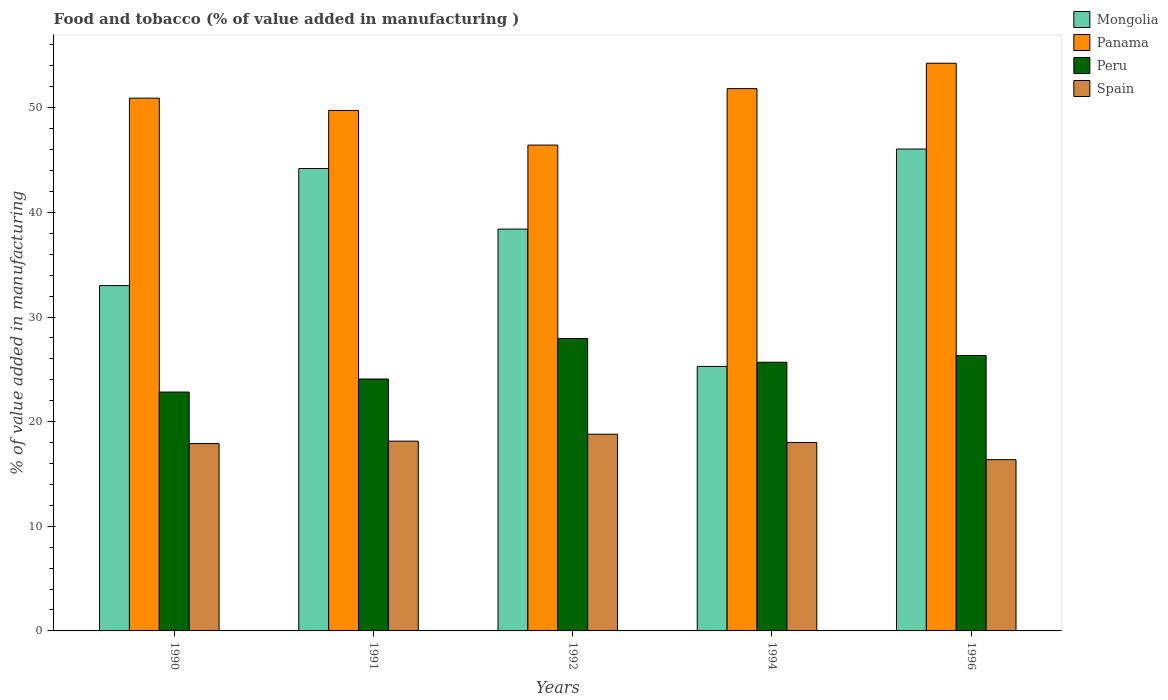How many different coloured bars are there?
Keep it short and to the point. 4. How many groups of bars are there?
Offer a very short reply. 5. Are the number of bars per tick equal to the number of legend labels?
Provide a succinct answer. Yes. How many bars are there on the 3rd tick from the right?
Provide a short and direct response. 4. In how many cases, is the number of bars for a given year not equal to the number of legend labels?
Ensure brevity in your answer.  0. What is the value added in manufacturing food and tobacco in Panama in 1992?
Make the answer very short. 46.43. Across all years, what is the maximum value added in manufacturing food and tobacco in Spain?
Your answer should be compact. 18.8. Across all years, what is the minimum value added in manufacturing food and tobacco in Spain?
Ensure brevity in your answer.  16.37. In which year was the value added in manufacturing food and tobacco in Panama maximum?
Your answer should be compact. 1996. What is the total value added in manufacturing food and tobacco in Mongolia in the graph?
Your answer should be very brief. 186.94. What is the difference between the value added in manufacturing food and tobacco in Panama in 1990 and that in 1991?
Your response must be concise. 1.17. What is the difference between the value added in manufacturing food and tobacco in Mongolia in 1996 and the value added in manufacturing food and tobacco in Spain in 1990?
Offer a terse response. 28.15. What is the average value added in manufacturing food and tobacco in Mongolia per year?
Make the answer very short. 37.39. In the year 1992, what is the difference between the value added in manufacturing food and tobacco in Panama and value added in manufacturing food and tobacco in Spain?
Give a very brief answer. 27.63. What is the ratio of the value added in manufacturing food and tobacco in Spain in 1991 to that in 1994?
Your answer should be compact. 1.01. Is the difference between the value added in manufacturing food and tobacco in Panama in 1990 and 1996 greater than the difference between the value added in manufacturing food and tobacco in Spain in 1990 and 1996?
Ensure brevity in your answer.  No. What is the difference between the highest and the second highest value added in manufacturing food and tobacco in Panama?
Offer a terse response. 2.42. What is the difference between the highest and the lowest value added in manufacturing food and tobacco in Panama?
Your answer should be very brief. 7.82. In how many years, is the value added in manufacturing food and tobacco in Mongolia greater than the average value added in manufacturing food and tobacco in Mongolia taken over all years?
Keep it short and to the point. 3. What does the 3rd bar from the left in 1990 represents?
Give a very brief answer. Peru. What does the 2nd bar from the right in 1991 represents?
Provide a succinct answer. Peru. How many bars are there?
Your response must be concise. 20. Are the values on the major ticks of Y-axis written in scientific E-notation?
Offer a terse response. No. Where does the legend appear in the graph?
Give a very brief answer. Top right. What is the title of the graph?
Ensure brevity in your answer.  Food and tobacco (% of value added in manufacturing ). What is the label or title of the X-axis?
Keep it short and to the point. Years. What is the label or title of the Y-axis?
Provide a succinct answer. % of value added in manufacturing. What is the % of value added in manufacturing in Mongolia in 1990?
Provide a short and direct response. 33.01. What is the % of value added in manufacturing in Panama in 1990?
Provide a short and direct response. 50.92. What is the % of value added in manufacturing of Peru in 1990?
Give a very brief answer. 22.83. What is the % of value added in manufacturing of Spain in 1990?
Give a very brief answer. 17.9. What is the % of value added in manufacturing in Mongolia in 1991?
Your answer should be compact. 44.2. What is the % of value added in manufacturing of Panama in 1991?
Offer a terse response. 49.75. What is the % of value added in manufacturing of Peru in 1991?
Offer a terse response. 24.08. What is the % of value added in manufacturing in Spain in 1991?
Your response must be concise. 18.14. What is the % of value added in manufacturing in Mongolia in 1992?
Offer a very short reply. 38.41. What is the % of value added in manufacturing in Panama in 1992?
Your answer should be compact. 46.43. What is the % of value added in manufacturing of Peru in 1992?
Ensure brevity in your answer.  27.95. What is the % of value added in manufacturing of Spain in 1992?
Provide a succinct answer. 18.8. What is the % of value added in manufacturing in Mongolia in 1994?
Make the answer very short. 25.28. What is the % of value added in manufacturing in Panama in 1994?
Provide a short and direct response. 51.83. What is the % of value added in manufacturing in Peru in 1994?
Your answer should be compact. 25.68. What is the % of value added in manufacturing in Spain in 1994?
Offer a very short reply. 18.01. What is the % of value added in manufacturing in Mongolia in 1996?
Give a very brief answer. 46.05. What is the % of value added in manufacturing in Panama in 1996?
Make the answer very short. 54.25. What is the % of value added in manufacturing in Peru in 1996?
Your response must be concise. 26.33. What is the % of value added in manufacturing of Spain in 1996?
Offer a terse response. 16.37. Across all years, what is the maximum % of value added in manufacturing in Mongolia?
Provide a short and direct response. 46.05. Across all years, what is the maximum % of value added in manufacturing in Panama?
Your response must be concise. 54.25. Across all years, what is the maximum % of value added in manufacturing in Peru?
Offer a terse response. 27.95. Across all years, what is the maximum % of value added in manufacturing of Spain?
Keep it short and to the point. 18.8. Across all years, what is the minimum % of value added in manufacturing of Mongolia?
Your response must be concise. 25.28. Across all years, what is the minimum % of value added in manufacturing in Panama?
Your answer should be compact. 46.43. Across all years, what is the minimum % of value added in manufacturing in Peru?
Ensure brevity in your answer.  22.83. Across all years, what is the minimum % of value added in manufacturing of Spain?
Ensure brevity in your answer.  16.37. What is the total % of value added in manufacturing of Mongolia in the graph?
Provide a succinct answer. 186.94. What is the total % of value added in manufacturing of Panama in the graph?
Provide a short and direct response. 253.18. What is the total % of value added in manufacturing of Peru in the graph?
Make the answer very short. 126.86. What is the total % of value added in manufacturing in Spain in the graph?
Keep it short and to the point. 89.22. What is the difference between the % of value added in manufacturing in Mongolia in 1990 and that in 1991?
Ensure brevity in your answer.  -11.19. What is the difference between the % of value added in manufacturing in Panama in 1990 and that in 1991?
Make the answer very short. 1.17. What is the difference between the % of value added in manufacturing of Peru in 1990 and that in 1991?
Make the answer very short. -1.25. What is the difference between the % of value added in manufacturing in Spain in 1990 and that in 1991?
Provide a succinct answer. -0.23. What is the difference between the % of value added in manufacturing in Mongolia in 1990 and that in 1992?
Offer a very short reply. -5.4. What is the difference between the % of value added in manufacturing of Panama in 1990 and that in 1992?
Make the answer very short. 4.48. What is the difference between the % of value added in manufacturing in Peru in 1990 and that in 1992?
Keep it short and to the point. -5.12. What is the difference between the % of value added in manufacturing in Spain in 1990 and that in 1992?
Provide a succinct answer. -0.89. What is the difference between the % of value added in manufacturing in Mongolia in 1990 and that in 1994?
Offer a terse response. 7.73. What is the difference between the % of value added in manufacturing of Panama in 1990 and that in 1994?
Give a very brief answer. -0.91. What is the difference between the % of value added in manufacturing of Peru in 1990 and that in 1994?
Your response must be concise. -2.85. What is the difference between the % of value added in manufacturing of Spain in 1990 and that in 1994?
Keep it short and to the point. -0.1. What is the difference between the % of value added in manufacturing in Mongolia in 1990 and that in 1996?
Provide a succinct answer. -13.05. What is the difference between the % of value added in manufacturing in Panama in 1990 and that in 1996?
Your answer should be very brief. -3.34. What is the difference between the % of value added in manufacturing in Peru in 1990 and that in 1996?
Offer a terse response. -3.5. What is the difference between the % of value added in manufacturing in Spain in 1990 and that in 1996?
Offer a very short reply. 1.54. What is the difference between the % of value added in manufacturing of Mongolia in 1991 and that in 1992?
Your answer should be very brief. 5.79. What is the difference between the % of value added in manufacturing in Panama in 1991 and that in 1992?
Offer a very short reply. 3.31. What is the difference between the % of value added in manufacturing in Peru in 1991 and that in 1992?
Your answer should be very brief. -3.87. What is the difference between the % of value added in manufacturing of Spain in 1991 and that in 1992?
Keep it short and to the point. -0.66. What is the difference between the % of value added in manufacturing in Mongolia in 1991 and that in 1994?
Your answer should be very brief. 18.92. What is the difference between the % of value added in manufacturing in Panama in 1991 and that in 1994?
Your answer should be very brief. -2.09. What is the difference between the % of value added in manufacturing in Peru in 1991 and that in 1994?
Keep it short and to the point. -1.6. What is the difference between the % of value added in manufacturing of Spain in 1991 and that in 1994?
Provide a short and direct response. 0.13. What is the difference between the % of value added in manufacturing of Mongolia in 1991 and that in 1996?
Make the answer very short. -1.86. What is the difference between the % of value added in manufacturing of Panama in 1991 and that in 1996?
Offer a terse response. -4.51. What is the difference between the % of value added in manufacturing of Peru in 1991 and that in 1996?
Provide a succinct answer. -2.25. What is the difference between the % of value added in manufacturing in Spain in 1991 and that in 1996?
Keep it short and to the point. 1.77. What is the difference between the % of value added in manufacturing in Mongolia in 1992 and that in 1994?
Your answer should be compact. 13.13. What is the difference between the % of value added in manufacturing in Panama in 1992 and that in 1994?
Make the answer very short. -5.4. What is the difference between the % of value added in manufacturing of Peru in 1992 and that in 1994?
Your answer should be very brief. 2.27. What is the difference between the % of value added in manufacturing of Spain in 1992 and that in 1994?
Keep it short and to the point. 0.79. What is the difference between the % of value added in manufacturing of Mongolia in 1992 and that in 1996?
Provide a short and direct response. -7.65. What is the difference between the % of value added in manufacturing in Panama in 1992 and that in 1996?
Your response must be concise. -7.82. What is the difference between the % of value added in manufacturing in Peru in 1992 and that in 1996?
Your answer should be very brief. 1.62. What is the difference between the % of value added in manufacturing of Spain in 1992 and that in 1996?
Make the answer very short. 2.43. What is the difference between the % of value added in manufacturing of Mongolia in 1994 and that in 1996?
Your answer should be very brief. -20.78. What is the difference between the % of value added in manufacturing of Panama in 1994 and that in 1996?
Your response must be concise. -2.42. What is the difference between the % of value added in manufacturing in Peru in 1994 and that in 1996?
Offer a very short reply. -0.65. What is the difference between the % of value added in manufacturing of Spain in 1994 and that in 1996?
Provide a succinct answer. 1.64. What is the difference between the % of value added in manufacturing of Mongolia in 1990 and the % of value added in manufacturing of Panama in 1991?
Provide a short and direct response. -16.74. What is the difference between the % of value added in manufacturing of Mongolia in 1990 and the % of value added in manufacturing of Peru in 1991?
Ensure brevity in your answer.  8.93. What is the difference between the % of value added in manufacturing in Mongolia in 1990 and the % of value added in manufacturing in Spain in 1991?
Offer a very short reply. 14.87. What is the difference between the % of value added in manufacturing of Panama in 1990 and the % of value added in manufacturing of Peru in 1991?
Make the answer very short. 26.84. What is the difference between the % of value added in manufacturing in Panama in 1990 and the % of value added in manufacturing in Spain in 1991?
Provide a succinct answer. 32.78. What is the difference between the % of value added in manufacturing in Peru in 1990 and the % of value added in manufacturing in Spain in 1991?
Offer a terse response. 4.69. What is the difference between the % of value added in manufacturing of Mongolia in 1990 and the % of value added in manufacturing of Panama in 1992?
Your response must be concise. -13.43. What is the difference between the % of value added in manufacturing in Mongolia in 1990 and the % of value added in manufacturing in Peru in 1992?
Give a very brief answer. 5.06. What is the difference between the % of value added in manufacturing of Mongolia in 1990 and the % of value added in manufacturing of Spain in 1992?
Your answer should be compact. 14.21. What is the difference between the % of value added in manufacturing of Panama in 1990 and the % of value added in manufacturing of Peru in 1992?
Give a very brief answer. 22.97. What is the difference between the % of value added in manufacturing in Panama in 1990 and the % of value added in manufacturing in Spain in 1992?
Your response must be concise. 32.12. What is the difference between the % of value added in manufacturing of Peru in 1990 and the % of value added in manufacturing of Spain in 1992?
Keep it short and to the point. 4.03. What is the difference between the % of value added in manufacturing in Mongolia in 1990 and the % of value added in manufacturing in Panama in 1994?
Give a very brief answer. -18.82. What is the difference between the % of value added in manufacturing of Mongolia in 1990 and the % of value added in manufacturing of Peru in 1994?
Make the answer very short. 7.33. What is the difference between the % of value added in manufacturing in Mongolia in 1990 and the % of value added in manufacturing in Spain in 1994?
Provide a succinct answer. 15. What is the difference between the % of value added in manufacturing of Panama in 1990 and the % of value added in manufacturing of Peru in 1994?
Give a very brief answer. 25.24. What is the difference between the % of value added in manufacturing of Panama in 1990 and the % of value added in manufacturing of Spain in 1994?
Provide a succinct answer. 32.91. What is the difference between the % of value added in manufacturing of Peru in 1990 and the % of value added in manufacturing of Spain in 1994?
Your response must be concise. 4.82. What is the difference between the % of value added in manufacturing of Mongolia in 1990 and the % of value added in manufacturing of Panama in 1996?
Give a very brief answer. -21.25. What is the difference between the % of value added in manufacturing of Mongolia in 1990 and the % of value added in manufacturing of Peru in 1996?
Offer a terse response. 6.68. What is the difference between the % of value added in manufacturing in Mongolia in 1990 and the % of value added in manufacturing in Spain in 1996?
Offer a very short reply. 16.64. What is the difference between the % of value added in manufacturing in Panama in 1990 and the % of value added in manufacturing in Peru in 1996?
Your response must be concise. 24.59. What is the difference between the % of value added in manufacturing of Panama in 1990 and the % of value added in manufacturing of Spain in 1996?
Your answer should be compact. 34.55. What is the difference between the % of value added in manufacturing of Peru in 1990 and the % of value added in manufacturing of Spain in 1996?
Provide a succinct answer. 6.46. What is the difference between the % of value added in manufacturing in Mongolia in 1991 and the % of value added in manufacturing in Panama in 1992?
Offer a terse response. -2.24. What is the difference between the % of value added in manufacturing in Mongolia in 1991 and the % of value added in manufacturing in Peru in 1992?
Offer a terse response. 16.25. What is the difference between the % of value added in manufacturing of Mongolia in 1991 and the % of value added in manufacturing of Spain in 1992?
Offer a very short reply. 25.4. What is the difference between the % of value added in manufacturing in Panama in 1991 and the % of value added in manufacturing in Peru in 1992?
Your answer should be compact. 21.8. What is the difference between the % of value added in manufacturing of Panama in 1991 and the % of value added in manufacturing of Spain in 1992?
Make the answer very short. 30.95. What is the difference between the % of value added in manufacturing of Peru in 1991 and the % of value added in manufacturing of Spain in 1992?
Provide a succinct answer. 5.28. What is the difference between the % of value added in manufacturing in Mongolia in 1991 and the % of value added in manufacturing in Panama in 1994?
Give a very brief answer. -7.64. What is the difference between the % of value added in manufacturing in Mongolia in 1991 and the % of value added in manufacturing in Peru in 1994?
Ensure brevity in your answer.  18.52. What is the difference between the % of value added in manufacturing of Mongolia in 1991 and the % of value added in manufacturing of Spain in 1994?
Keep it short and to the point. 26.19. What is the difference between the % of value added in manufacturing in Panama in 1991 and the % of value added in manufacturing in Peru in 1994?
Provide a succinct answer. 24.07. What is the difference between the % of value added in manufacturing in Panama in 1991 and the % of value added in manufacturing in Spain in 1994?
Offer a terse response. 31.74. What is the difference between the % of value added in manufacturing in Peru in 1991 and the % of value added in manufacturing in Spain in 1994?
Give a very brief answer. 6.07. What is the difference between the % of value added in manufacturing in Mongolia in 1991 and the % of value added in manufacturing in Panama in 1996?
Offer a very short reply. -10.06. What is the difference between the % of value added in manufacturing of Mongolia in 1991 and the % of value added in manufacturing of Peru in 1996?
Provide a short and direct response. 17.87. What is the difference between the % of value added in manufacturing of Mongolia in 1991 and the % of value added in manufacturing of Spain in 1996?
Offer a very short reply. 27.83. What is the difference between the % of value added in manufacturing in Panama in 1991 and the % of value added in manufacturing in Peru in 1996?
Offer a very short reply. 23.42. What is the difference between the % of value added in manufacturing in Panama in 1991 and the % of value added in manufacturing in Spain in 1996?
Ensure brevity in your answer.  33.38. What is the difference between the % of value added in manufacturing in Peru in 1991 and the % of value added in manufacturing in Spain in 1996?
Your answer should be very brief. 7.71. What is the difference between the % of value added in manufacturing of Mongolia in 1992 and the % of value added in manufacturing of Panama in 1994?
Keep it short and to the point. -13.43. What is the difference between the % of value added in manufacturing of Mongolia in 1992 and the % of value added in manufacturing of Peru in 1994?
Your answer should be compact. 12.73. What is the difference between the % of value added in manufacturing of Mongolia in 1992 and the % of value added in manufacturing of Spain in 1994?
Your answer should be compact. 20.4. What is the difference between the % of value added in manufacturing in Panama in 1992 and the % of value added in manufacturing in Peru in 1994?
Your answer should be very brief. 20.75. What is the difference between the % of value added in manufacturing of Panama in 1992 and the % of value added in manufacturing of Spain in 1994?
Your answer should be compact. 28.43. What is the difference between the % of value added in manufacturing of Peru in 1992 and the % of value added in manufacturing of Spain in 1994?
Your response must be concise. 9.94. What is the difference between the % of value added in manufacturing in Mongolia in 1992 and the % of value added in manufacturing in Panama in 1996?
Provide a short and direct response. -15.85. What is the difference between the % of value added in manufacturing of Mongolia in 1992 and the % of value added in manufacturing of Peru in 1996?
Keep it short and to the point. 12.08. What is the difference between the % of value added in manufacturing in Mongolia in 1992 and the % of value added in manufacturing in Spain in 1996?
Your answer should be very brief. 22.04. What is the difference between the % of value added in manufacturing in Panama in 1992 and the % of value added in manufacturing in Peru in 1996?
Your answer should be very brief. 20.11. What is the difference between the % of value added in manufacturing in Panama in 1992 and the % of value added in manufacturing in Spain in 1996?
Ensure brevity in your answer.  30.07. What is the difference between the % of value added in manufacturing in Peru in 1992 and the % of value added in manufacturing in Spain in 1996?
Provide a short and direct response. 11.58. What is the difference between the % of value added in manufacturing in Mongolia in 1994 and the % of value added in manufacturing in Panama in 1996?
Offer a terse response. -28.98. What is the difference between the % of value added in manufacturing in Mongolia in 1994 and the % of value added in manufacturing in Peru in 1996?
Your answer should be very brief. -1.05. What is the difference between the % of value added in manufacturing of Mongolia in 1994 and the % of value added in manufacturing of Spain in 1996?
Make the answer very short. 8.91. What is the difference between the % of value added in manufacturing of Panama in 1994 and the % of value added in manufacturing of Peru in 1996?
Your answer should be compact. 25.51. What is the difference between the % of value added in manufacturing in Panama in 1994 and the % of value added in manufacturing in Spain in 1996?
Your response must be concise. 35.46. What is the difference between the % of value added in manufacturing of Peru in 1994 and the % of value added in manufacturing of Spain in 1996?
Provide a succinct answer. 9.31. What is the average % of value added in manufacturing in Mongolia per year?
Your response must be concise. 37.39. What is the average % of value added in manufacturing of Panama per year?
Offer a very short reply. 50.64. What is the average % of value added in manufacturing of Peru per year?
Your answer should be compact. 25.37. What is the average % of value added in manufacturing in Spain per year?
Your answer should be very brief. 17.84. In the year 1990, what is the difference between the % of value added in manufacturing of Mongolia and % of value added in manufacturing of Panama?
Make the answer very short. -17.91. In the year 1990, what is the difference between the % of value added in manufacturing of Mongolia and % of value added in manufacturing of Peru?
Offer a terse response. 10.18. In the year 1990, what is the difference between the % of value added in manufacturing in Mongolia and % of value added in manufacturing in Spain?
Ensure brevity in your answer.  15.1. In the year 1990, what is the difference between the % of value added in manufacturing of Panama and % of value added in manufacturing of Peru?
Provide a short and direct response. 28.09. In the year 1990, what is the difference between the % of value added in manufacturing in Panama and % of value added in manufacturing in Spain?
Your answer should be very brief. 33.01. In the year 1990, what is the difference between the % of value added in manufacturing in Peru and % of value added in manufacturing in Spain?
Provide a succinct answer. 4.92. In the year 1991, what is the difference between the % of value added in manufacturing in Mongolia and % of value added in manufacturing in Panama?
Keep it short and to the point. -5.55. In the year 1991, what is the difference between the % of value added in manufacturing in Mongolia and % of value added in manufacturing in Peru?
Provide a short and direct response. 20.12. In the year 1991, what is the difference between the % of value added in manufacturing of Mongolia and % of value added in manufacturing of Spain?
Make the answer very short. 26.06. In the year 1991, what is the difference between the % of value added in manufacturing in Panama and % of value added in manufacturing in Peru?
Provide a succinct answer. 25.67. In the year 1991, what is the difference between the % of value added in manufacturing of Panama and % of value added in manufacturing of Spain?
Offer a very short reply. 31.61. In the year 1991, what is the difference between the % of value added in manufacturing of Peru and % of value added in manufacturing of Spain?
Provide a succinct answer. 5.94. In the year 1992, what is the difference between the % of value added in manufacturing of Mongolia and % of value added in manufacturing of Panama?
Your answer should be very brief. -8.03. In the year 1992, what is the difference between the % of value added in manufacturing in Mongolia and % of value added in manufacturing in Peru?
Offer a very short reply. 10.46. In the year 1992, what is the difference between the % of value added in manufacturing in Mongolia and % of value added in manufacturing in Spain?
Offer a very short reply. 19.61. In the year 1992, what is the difference between the % of value added in manufacturing of Panama and % of value added in manufacturing of Peru?
Make the answer very short. 18.48. In the year 1992, what is the difference between the % of value added in manufacturing in Panama and % of value added in manufacturing in Spain?
Give a very brief answer. 27.63. In the year 1992, what is the difference between the % of value added in manufacturing in Peru and % of value added in manufacturing in Spain?
Make the answer very short. 9.15. In the year 1994, what is the difference between the % of value added in manufacturing in Mongolia and % of value added in manufacturing in Panama?
Give a very brief answer. -26.55. In the year 1994, what is the difference between the % of value added in manufacturing in Mongolia and % of value added in manufacturing in Spain?
Your answer should be compact. 7.27. In the year 1994, what is the difference between the % of value added in manufacturing in Panama and % of value added in manufacturing in Peru?
Your response must be concise. 26.15. In the year 1994, what is the difference between the % of value added in manufacturing of Panama and % of value added in manufacturing of Spain?
Offer a terse response. 33.82. In the year 1994, what is the difference between the % of value added in manufacturing of Peru and % of value added in manufacturing of Spain?
Make the answer very short. 7.67. In the year 1996, what is the difference between the % of value added in manufacturing of Mongolia and % of value added in manufacturing of Panama?
Your answer should be very brief. -8.2. In the year 1996, what is the difference between the % of value added in manufacturing of Mongolia and % of value added in manufacturing of Peru?
Your answer should be compact. 19.73. In the year 1996, what is the difference between the % of value added in manufacturing of Mongolia and % of value added in manufacturing of Spain?
Keep it short and to the point. 29.69. In the year 1996, what is the difference between the % of value added in manufacturing in Panama and % of value added in manufacturing in Peru?
Provide a succinct answer. 27.93. In the year 1996, what is the difference between the % of value added in manufacturing of Panama and % of value added in manufacturing of Spain?
Your answer should be compact. 37.89. In the year 1996, what is the difference between the % of value added in manufacturing in Peru and % of value added in manufacturing in Spain?
Give a very brief answer. 9.96. What is the ratio of the % of value added in manufacturing in Mongolia in 1990 to that in 1991?
Your answer should be very brief. 0.75. What is the ratio of the % of value added in manufacturing of Panama in 1990 to that in 1991?
Your response must be concise. 1.02. What is the ratio of the % of value added in manufacturing in Peru in 1990 to that in 1991?
Offer a very short reply. 0.95. What is the ratio of the % of value added in manufacturing in Spain in 1990 to that in 1991?
Offer a terse response. 0.99. What is the ratio of the % of value added in manufacturing of Mongolia in 1990 to that in 1992?
Give a very brief answer. 0.86. What is the ratio of the % of value added in manufacturing of Panama in 1990 to that in 1992?
Ensure brevity in your answer.  1.1. What is the ratio of the % of value added in manufacturing of Peru in 1990 to that in 1992?
Your answer should be compact. 0.82. What is the ratio of the % of value added in manufacturing of Spain in 1990 to that in 1992?
Make the answer very short. 0.95. What is the ratio of the % of value added in manufacturing of Mongolia in 1990 to that in 1994?
Make the answer very short. 1.31. What is the ratio of the % of value added in manufacturing of Panama in 1990 to that in 1994?
Your answer should be very brief. 0.98. What is the ratio of the % of value added in manufacturing of Peru in 1990 to that in 1994?
Your answer should be compact. 0.89. What is the ratio of the % of value added in manufacturing of Mongolia in 1990 to that in 1996?
Your answer should be compact. 0.72. What is the ratio of the % of value added in manufacturing of Panama in 1990 to that in 1996?
Your answer should be very brief. 0.94. What is the ratio of the % of value added in manufacturing of Peru in 1990 to that in 1996?
Your answer should be very brief. 0.87. What is the ratio of the % of value added in manufacturing of Spain in 1990 to that in 1996?
Your answer should be compact. 1.09. What is the ratio of the % of value added in manufacturing in Mongolia in 1991 to that in 1992?
Your answer should be very brief. 1.15. What is the ratio of the % of value added in manufacturing of Panama in 1991 to that in 1992?
Provide a succinct answer. 1.07. What is the ratio of the % of value added in manufacturing of Peru in 1991 to that in 1992?
Your answer should be compact. 0.86. What is the ratio of the % of value added in manufacturing of Spain in 1991 to that in 1992?
Give a very brief answer. 0.96. What is the ratio of the % of value added in manufacturing in Mongolia in 1991 to that in 1994?
Make the answer very short. 1.75. What is the ratio of the % of value added in manufacturing of Panama in 1991 to that in 1994?
Keep it short and to the point. 0.96. What is the ratio of the % of value added in manufacturing of Peru in 1991 to that in 1994?
Your response must be concise. 0.94. What is the ratio of the % of value added in manufacturing in Spain in 1991 to that in 1994?
Offer a very short reply. 1.01. What is the ratio of the % of value added in manufacturing in Mongolia in 1991 to that in 1996?
Offer a very short reply. 0.96. What is the ratio of the % of value added in manufacturing of Panama in 1991 to that in 1996?
Make the answer very short. 0.92. What is the ratio of the % of value added in manufacturing of Peru in 1991 to that in 1996?
Your answer should be very brief. 0.91. What is the ratio of the % of value added in manufacturing of Spain in 1991 to that in 1996?
Provide a short and direct response. 1.11. What is the ratio of the % of value added in manufacturing of Mongolia in 1992 to that in 1994?
Offer a terse response. 1.52. What is the ratio of the % of value added in manufacturing of Panama in 1992 to that in 1994?
Offer a very short reply. 0.9. What is the ratio of the % of value added in manufacturing of Peru in 1992 to that in 1994?
Your answer should be very brief. 1.09. What is the ratio of the % of value added in manufacturing in Spain in 1992 to that in 1994?
Ensure brevity in your answer.  1.04. What is the ratio of the % of value added in manufacturing in Mongolia in 1992 to that in 1996?
Provide a short and direct response. 0.83. What is the ratio of the % of value added in manufacturing in Panama in 1992 to that in 1996?
Offer a very short reply. 0.86. What is the ratio of the % of value added in manufacturing in Peru in 1992 to that in 1996?
Your response must be concise. 1.06. What is the ratio of the % of value added in manufacturing of Spain in 1992 to that in 1996?
Your answer should be compact. 1.15. What is the ratio of the % of value added in manufacturing of Mongolia in 1994 to that in 1996?
Offer a terse response. 0.55. What is the ratio of the % of value added in manufacturing in Panama in 1994 to that in 1996?
Your answer should be very brief. 0.96. What is the ratio of the % of value added in manufacturing in Peru in 1994 to that in 1996?
Your response must be concise. 0.98. What is the ratio of the % of value added in manufacturing of Spain in 1994 to that in 1996?
Your answer should be compact. 1.1. What is the difference between the highest and the second highest % of value added in manufacturing in Mongolia?
Your response must be concise. 1.86. What is the difference between the highest and the second highest % of value added in manufacturing in Panama?
Give a very brief answer. 2.42. What is the difference between the highest and the second highest % of value added in manufacturing in Peru?
Offer a very short reply. 1.62. What is the difference between the highest and the second highest % of value added in manufacturing in Spain?
Offer a terse response. 0.66. What is the difference between the highest and the lowest % of value added in manufacturing of Mongolia?
Offer a very short reply. 20.78. What is the difference between the highest and the lowest % of value added in manufacturing in Panama?
Ensure brevity in your answer.  7.82. What is the difference between the highest and the lowest % of value added in manufacturing in Peru?
Provide a succinct answer. 5.12. What is the difference between the highest and the lowest % of value added in manufacturing in Spain?
Ensure brevity in your answer.  2.43. 